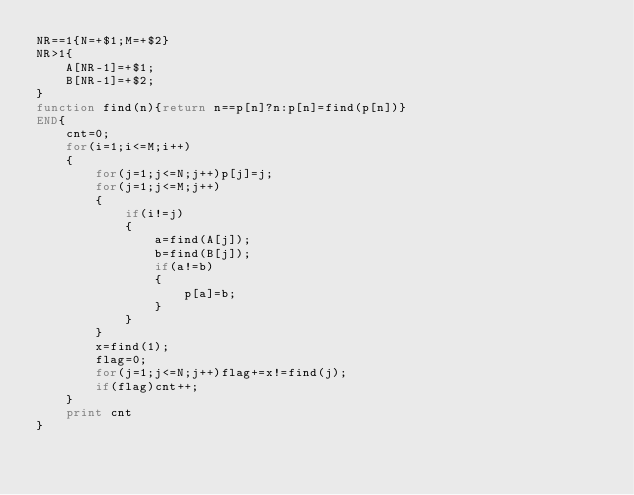<code> <loc_0><loc_0><loc_500><loc_500><_Awk_>NR==1{N=+$1;M=+$2}
NR>1{
	A[NR-1]=+$1;
	B[NR-1]=+$2;
}
function find(n){return n==p[n]?n:p[n]=find(p[n])}
END{
	cnt=0;
	for(i=1;i<=M;i++)
	{
		for(j=1;j<=N;j++)p[j]=j;
		for(j=1;j<=M;j++)
		{
			if(i!=j)
			{
				a=find(A[j]);
				b=find(B[j]);
				if(a!=b)
				{
					p[a]=b;
				}
			}
		}
		x=find(1);
		flag=0;
		for(j=1;j<=N;j++)flag+=x!=find(j);
		if(flag)cnt++;
	}
	print cnt
}
</code> 